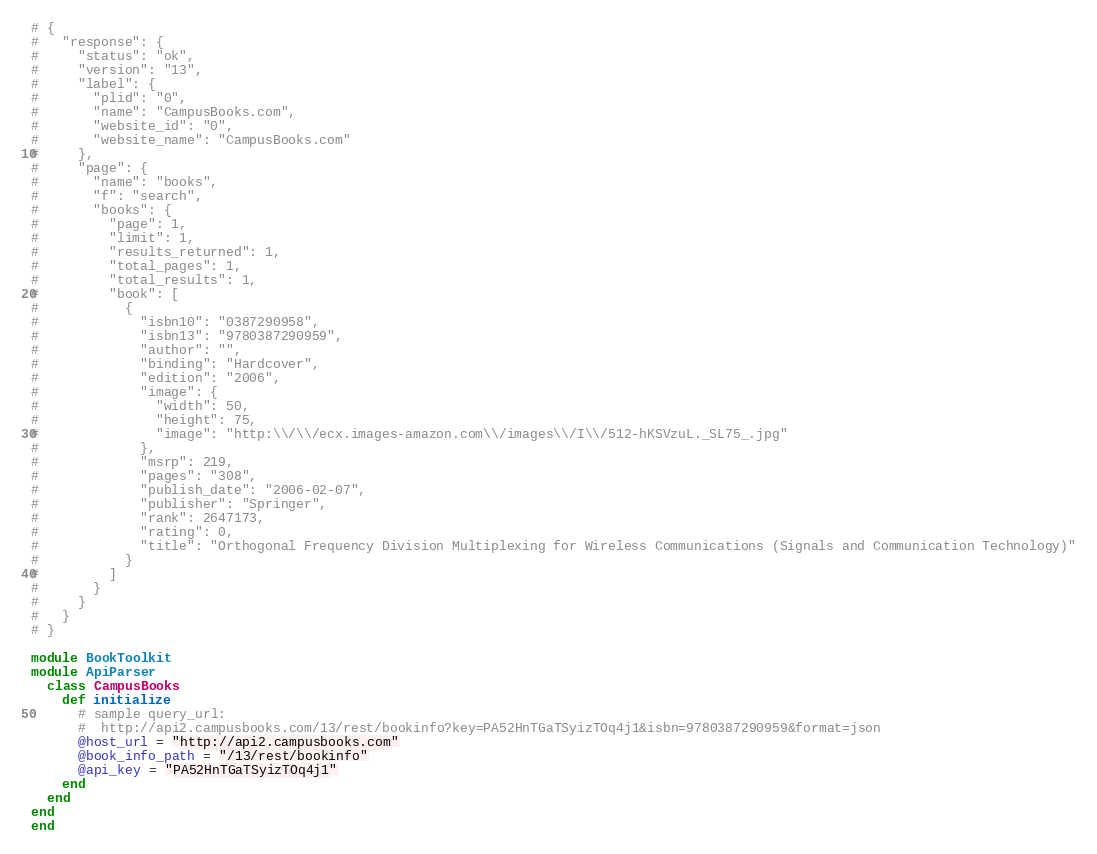Convert code to text. <code><loc_0><loc_0><loc_500><loc_500><_Ruby_># {
#   "response": {
#     "status": "ok",
#     "version": "13",
#     "label": {
#       "plid": "0",
#       "name": "CampusBooks.com",
#       "website_id": "0",
#       "website_name": "CampusBooks.com"
#     },
#     "page": {
#       "name": "books",
#       "f": "search",
#       "books": {
#         "page": 1,
#         "limit": 1,
#         "results_returned": 1,
#         "total_pages": 1,
#         "total_results": 1,
#         "book": [
#           {
#             "isbn10": "0387290958",
#             "isbn13": "9780387290959",
#             "author": "",
#             "binding": "Hardcover",
#             "edition": "2006",
#             "image": {
#               "width": 50,
#               "height": 75,
#               "image": "http:\\/\\/ecx.images-amazon.com\\/images\\/I\\/512-hKSVzuL._SL75_.jpg"
#             },
#             "msrp": 219,
#             "pages": "308",
#             "publish_date": "2006-02-07",
#             "publisher": "Springer",
#             "rank": 2647173,
#             "rating": 0,
#             "title": "Orthogonal Frequency Division Multiplexing for Wireless Communications (Signals and Communication Technology)"
#           }
#         ]
#       }
#     }
#   }
# }

module BookToolkit
module ApiParser
  class CampusBooks
    def initialize
      # sample query_url:
      #  http://api2.campusbooks.com/13/rest/bookinfo?key=PA52HnTGaTSyizTOq4j1&isbn=9780387290959&format=json
      @host_url = "http://api2.campusbooks.com"
      @book_info_path = "/13/rest/bookinfo"
      @api_key = "PA52HnTGaTSyizTOq4j1"
    end
  end
end
end
</code> 